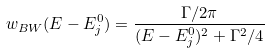<formula> <loc_0><loc_0><loc_500><loc_500>w _ { B W } ( E - E ^ { 0 } _ { j } ) = \frac { \Gamma / 2 \pi } { ( E - E ^ { 0 } _ { j } ) ^ { 2 } + \Gamma ^ { 2 } / 4 }</formula> 